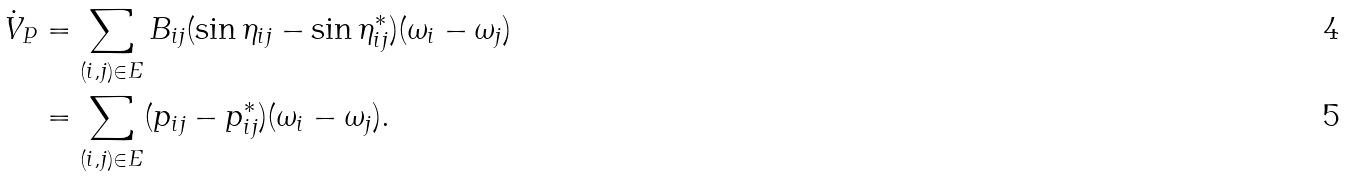<formula> <loc_0><loc_0><loc_500><loc_500>\dot { V } _ { P } & = \sum _ { ( i , j ) \in E } B _ { i j } ( \sin \eta _ { i j } - \sin \eta ^ { * } _ { i j } ) ( \omega _ { i } - \omega _ { j } ) \\ & = \sum _ { ( i , j ) \in E } ( p _ { i j } - p ^ { * } _ { i j } ) ( \omega _ { i } - \omega _ { j } ) .</formula> 